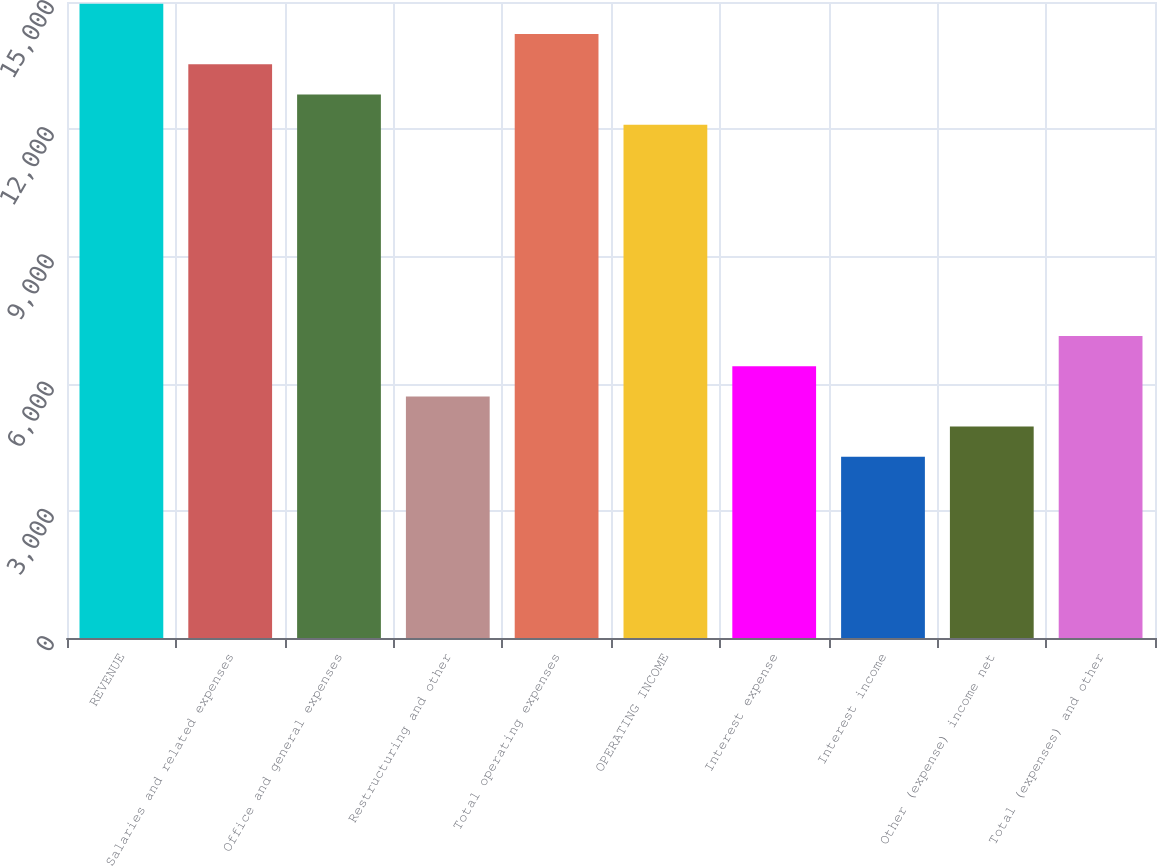Convert chart to OTSL. <chart><loc_0><loc_0><loc_500><loc_500><bar_chart><fcel>REVENUE<fcel>Salaries and related expenses<fcel>Office and general expenses<fcel>Restructuring and other<fcel>Total operating expenses<fcel>OPERATING INCOME<fcel>Interest expense<fcel>Interest income<fcel>Other (expense) income net<fcel>Total (expenses) and other<nl><fcel>14956.5<fcel>13532.1<fcel>12819.9<fcel>5697.9<fcel>14244.3<fcel>12107.7<fcel>6410.1<fcel>4273.5<fcel>4985.7<fcel>7122.3<nl></chart> 